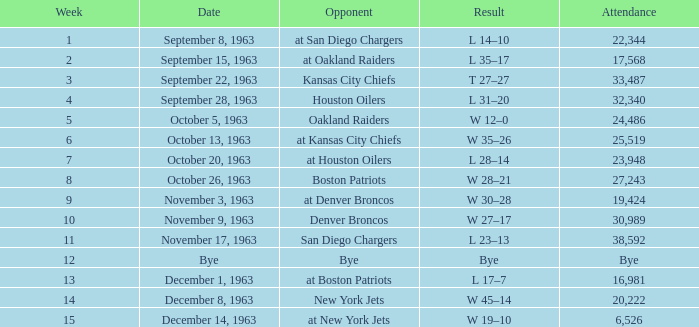Which Opponent has a Date of november 17, 1963? San Diego Chargers. 